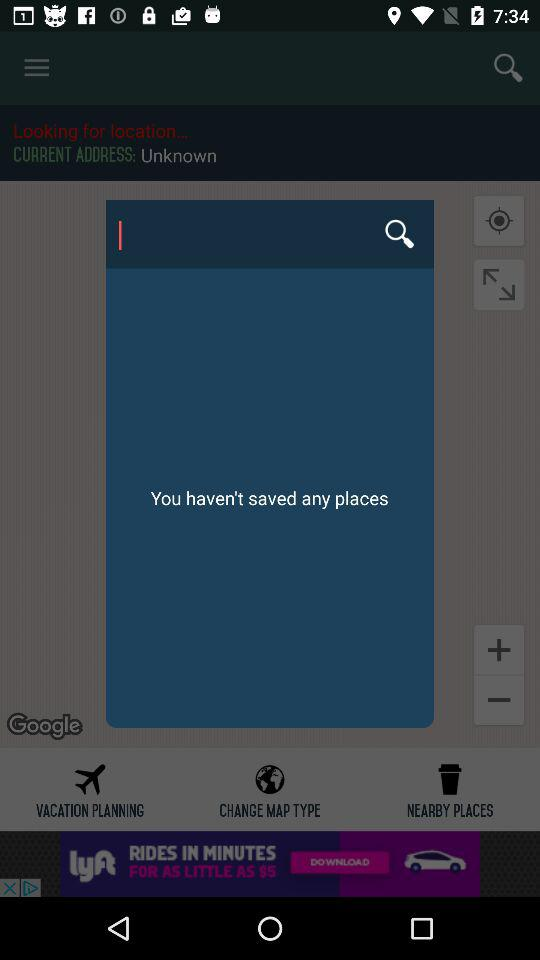What is the current address? The current address is unknown. 